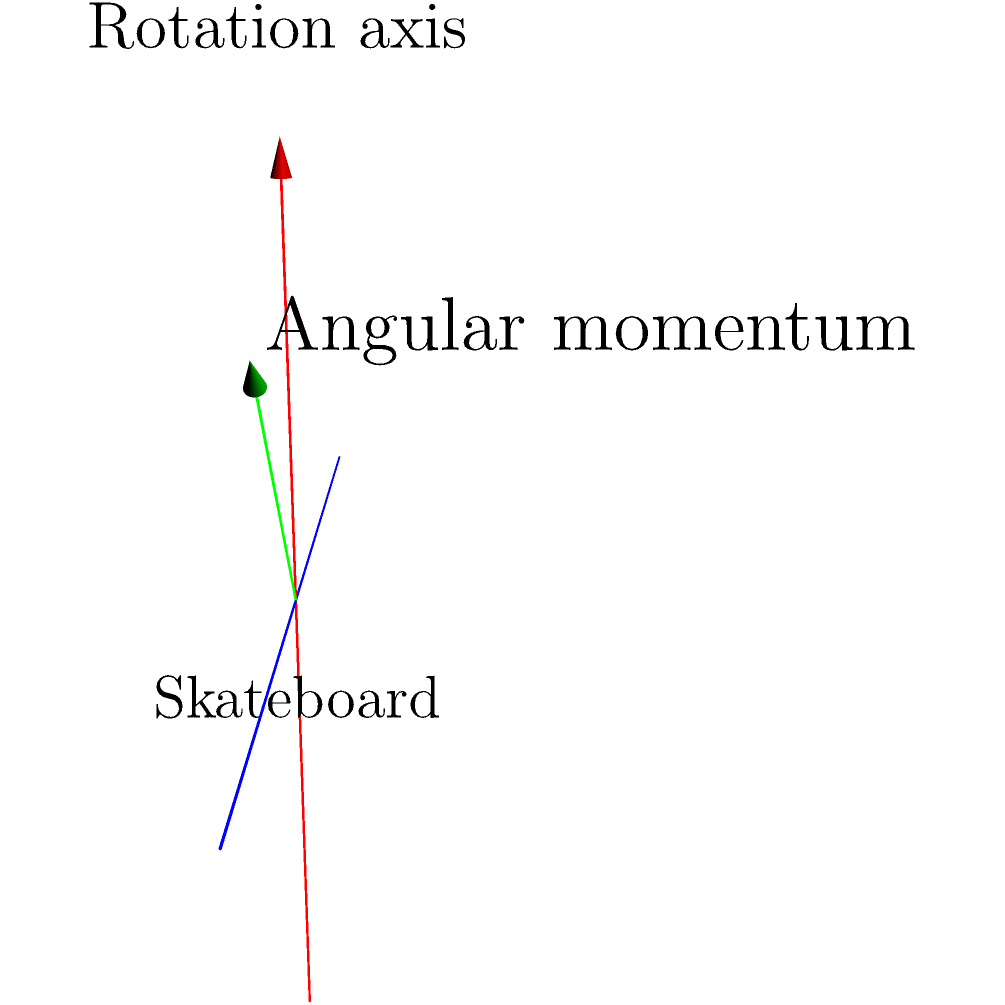In a 360 flip, the skateboard rotates around its longitudinal axis while also flipping. Based on the diagram, which shows the rotation axis and angular momentum vector during a 360 flip, what can you conclude about the relationship between these two vectors? To analyze the relationship between the rotation axis and the angular momentum vector in a 360 flip, let's break it down step-by-step:

1. Rotation axis: The red arrow in the diagram represents the rotation axis of the skateboard during a 360 flip. This axis is aligned with the longitudinal axis of the skateboard.

2. Angular momentum vector: The green arrow represents the angular momentum vector of the skateboard during the trick.

3. Vector orientation: Notice that the angular momentum vector is not parallel to the rotation axis. It has components both along the rotation axis and perpendicular to it.

4. Decomposition of angular momentum: We can decompose the angular momentum vector into two components:
   a. A component parallel to the rotation axis, contributing to the 360-degree rotation.
   b. A component perpendicular to the rotation axis, contributing to the flip.

5. Non-alignment: The fact that these vectors are not aligned indicates that the skateboard is undergoing a complex motion, combining rotation around its longitudinal axis (the 360 part) and a flip.

6. Conservation of angular momentum: During the trick, the total angular momentum is conserved, but its distribution between the two components can change, allowing for the combined rotating and flipping motion.

7. Precession: The non-alignment of these vectors also suggests that the skateboard may undergo a slight precession during the trick, which skilled skateboarders can control to perfect the landing.

In conclusion, the diagram shows that the angular momentum vector is not parallel to the rotation axis in a 360 flip, indicating a complex motion that combines rotation and flipping.
Answer: The angular momentum vector is not parallel to the rotation axis, indicating combined rotation and flipping motion. 